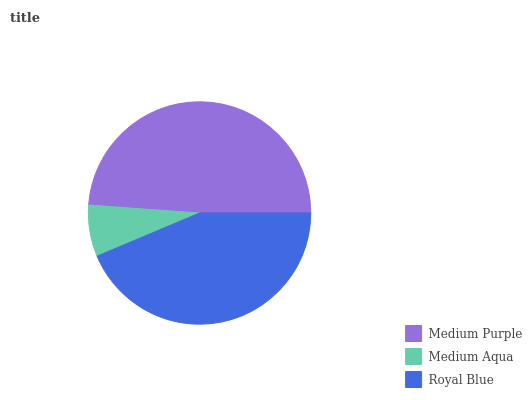Is Medium Aqua the minimum?
Answer yes or no. Yes. Is Medium Purple the maximum?
Answer yes or no. Yes. Is Royal Blue the minimum?
Answer yes or no. No. Is Royal Blue the maximum?
Answer yes or no. No. Is Royal Blue greater than Medium Aqua?
Answer yes or no. Yes. Is Medium Aqua less than Royal Blue?
Answer yes or no. Yes. Is Medium Aqua greater than Royal Blue?
Answer yes or no. No. Is Royal Blue less than Medium Aqua?
Answer yes or no. No. Is Royal Blue the high median?
Answer yes or no. Yes. Is Royal Blue the low median?
Answer yes or no. Yes. Is Medium Aqua the high median?
Answer yes or no. No. Is Medium Aqua the low median?
Answer yes or no. No. 